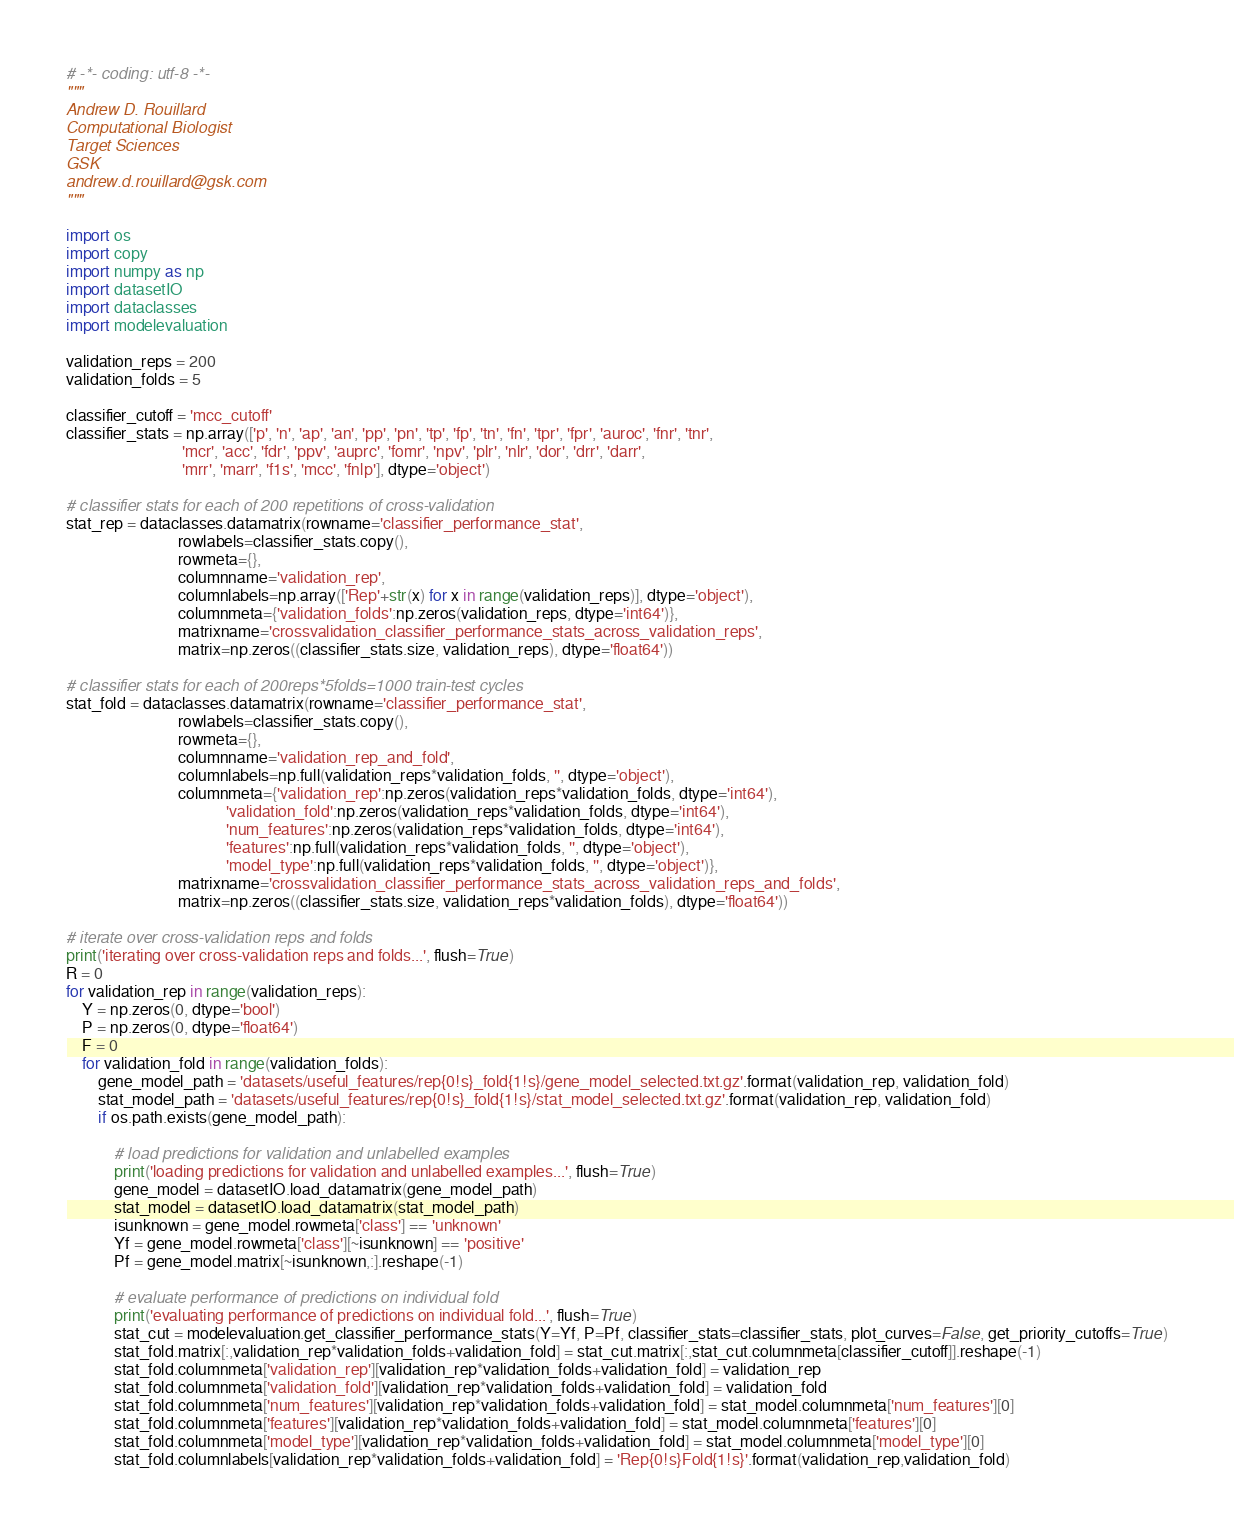Convert code to text. <code><loc_0><loc_0><loc_500><loc_500><_Python_># -*- coding: utf-8 -*-
"""
Andrew D. Rouillard
Computational Biologist
Target Sciences
GSK
andrew.d.rouillard@gsk.com
"""

import os
import copy
import numpy as np
import datasetIO
import dataclasses
import modelevaluation

validation_reps = 200
validation_folds = 5

classifier_cutoff = 'mcc_cutoff'
classifier_stats = np.array(['p', 'n', 'ap', 'an', 'pp', 'pn', 'tp', 'fp', 'tn', 'fn', 'tpr', 'fpr', 'auroc', 'fnr', 'tnr',
                             'mcr', 'acc', 'fdr', 'ppv', 'auprc', 'fomr', 'npv', 'plr', 'nlr', 'dor', 'drr', 'darr',
                             'mrr', 'marr', 'f1s', 'mcc', 'fnlp'], dtype='object')

# classifier stats for each of 200 repetitions of cross-validation
stat_rep = dataclasses.datamatrix(rowname='classifier_performance_stat',
                            rowlabels=classifier_stats.copy(),
                            rowmeta={},
                            columnname='validation_rep',
                            columnlabels=np.array(['Rep'+str(x) for x in range(validation_reps)], dtype='object'),
                            columnmeta={'validation_folds':np.zeros(validation_reps, dtype='int64')},
                            matrixname='crossvalidation_classifier_performance_stats_across_validation_reps',
                            matrix=np.zeros((classifier_stats.size, validation_reps), dtype='float64'))

# classifier stats for each of 200reps*5folds=1000 train-test cycles
stat_fold = dataclasses.datamatrix(rowname='classifier_performance_stat',
                            rowlabels=classifier_stats.copy(),
                            rowmeta={},
                            columnname='validation_rep_and_fold',
                            columnlabels=np.full(validation_reps*validation_folds, '', dtype='object'),
                            columnmeta={'validation_rep':np.zeros(validation_reps*validation_folds, dtype='int64'),
                                        'validation_fold':np.zeros(validation_reps*validation_folds, dtype='int64'),
                                        'num_features':np.zeros(validation_reps*validation_folds, dtype='int64'),
                                        'features':np.full(validation_reps*validation_folds, '', dtype='object'),
                                        'model_type':np.full(validation_reps*validation_folds, '', dtype='object')},
                            matrixname='crossvalidation_classifier_performance_stats_across_validation_reps_and_folds',
                            matrix=np.zeros((classifier_stats.size, validation_reps*validation_folds), dtype='float64'))

# iterate over cross-validation reps and folds
print('iterating over cross-validation reps and folds...', flush=True)
R = 0
for validation_rep in range(validation_reps):
    Y = np.zeros(0, dtype='bool')
    P = np.zeros(0, dtype='float64')
    F = 0
    for validation_fold in range(validation_folds):
        gene_model_path = 'datasets/useful_features/rep{0!s}_fold{1!s}/gene_model_selected.txt.gz'.format(validation_rep, validation_fold)        
        stat_model_path = 'datasets/useful_features/rep{0!s}_fold{1!s}/stat_model_selected.txt.gz'.format(validation_rep, validation_fold)        
        if os.path.exists(gene_model_path):
            
            # load predictions for validation and unlabelled examples
            print('loading predictions for validation and unlabelled examples...', flush=True)
            gene_model = datasetIO.load_datamatrix(gene_model_path)
            stat_model = datasetIO.load_datamatrix(stat_model_path)
            isunknown = gene_model.rowmeta['class'] == 'unknown'
            Yf = gene_model.rowmeta['class'][~isunknown] == 'positive'
            Pf = gene_model.matrix[~isunknown,:].reshape(-1)
            
            # evaluate performance of predictions on individual fold
            print('evaluating performance of predictions on individual fold...', flush=True)
            stat_cut = modelevaluation.get_classifier_performance_stats(Y=Yf, P=Pf, classifier_stats=classifier_stats, plot_curves=False, get_priority_cutoffs=True)
            stat_fold.matrix[:,validation_rep*validation_folds+validation_fold] = stat_cut.matrix[:,stat_cut.columnmeta[classifier_cutoff]].reshape(-1)
            stat_fold.columnmeta['validation_rep'][validation_rep*validation_folds+validation_fold] = validation_rep
            stat_fold.columnmeta['validation_fold'][validation_rep*validation_folds+validation_fold] = validation_fold
            stat_fold.columnmeta['num_features'][validation_rep*validation_folds+validation_fold] = stat_model.columnmeta['num_features'][0]
            stat_fold.columnmeta['features'][validation_rep*validation_folds+validation_fold] = stat_model.columnmeta['features'][0]
            stat_fold.columnmeta['model_type'][validation_rep*validation_folds+validation_fold] = stat_model.columnmeta['model_type'][0]
            stat_fold.columnlabels[validation_rep*validation_folds+validation_fold] = 'Rep{0!s}Fold{1!s}'.format(validation_rep,validation_fold)</code> 